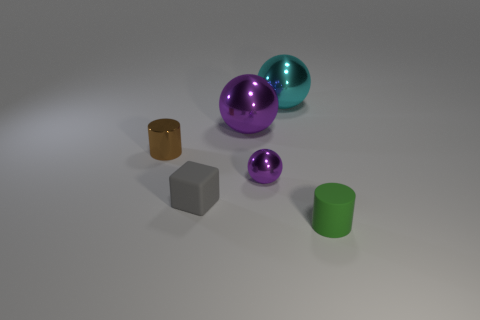Subtract all purple spheres. How many spheres are left? 1 Subtract all cyan balls. How many balls are left? 2 Subtract all blocks. How many objects are left? 5 Subtract 1 cubes. How many cubes are left? 0 Subtract all cyan spheres. How many purple cubes are left? 0 Subtract all cyan metallic objects. Subtract all big cyan blocks. How many objects are left? 5 Add 2 cyan metal objects. How many cyan metal objects are left? 3 Add 6 small purple metal balls. How many small purple metal balls exist? 7 Add 4 small gray rubber objects. How many objects exist? 10 Subtract 0 cyan blocks. How many objects are left? 6 